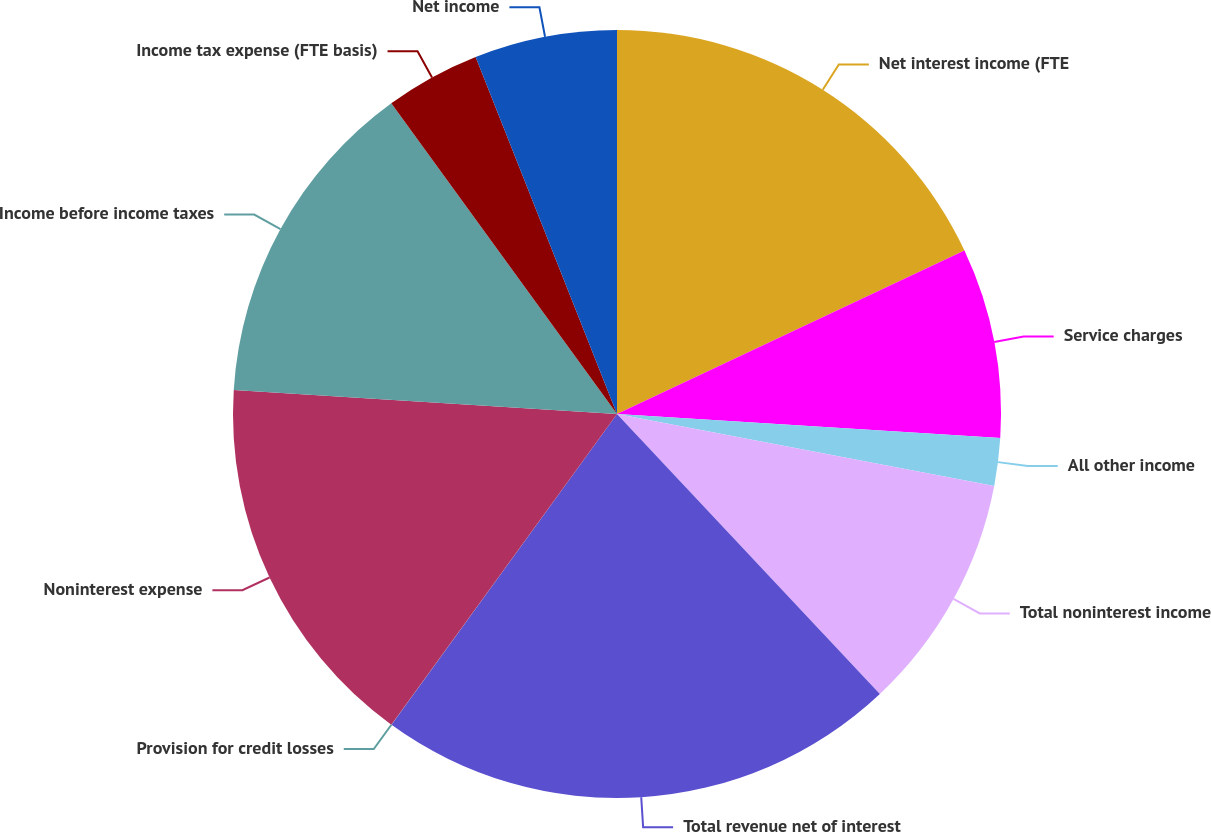Convert chart. <chart><loc_0><loc_0><loc_500><loc_500><pie_chart><fcel>Net interest income (FTE<fcel>Service charges<fcel>All other income<fcel>Total noninterest income<fcel>Total revenue net of interest<fcel>Provision for credit losses<fcel>Noninterest expense<fcel>Income before income taxes<fcel>Income tax expense (FTE basis)<fcel>Net income<nl><fcel>18.0%<fcel>8.0%<fcel>2.0%<fcel>10.0%<fcel>21.99%<fcel>0.01%<fcel>16.0%<fcel>14.0%<fcel>4.0%<fcel>6.0%<nl></chart> 